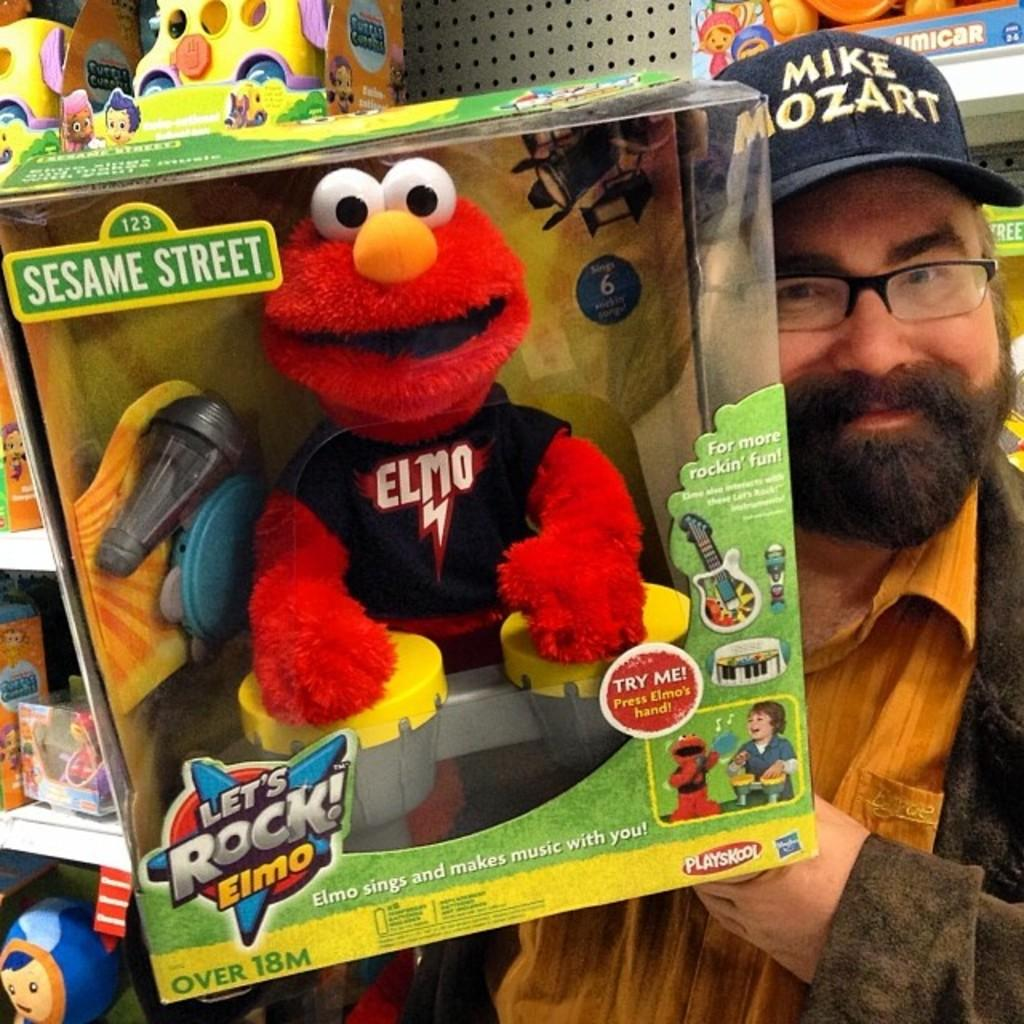Who is present in the image? There is a person in the image. What is the person wearing on their head? The person is wearing a cap. What is the person holding in the image? The person is holding toys. Are there any other toys visible in the image? Yes, there are other toys visible in the image. Where is the faucet located in the image? There is no faucet present in the image. 